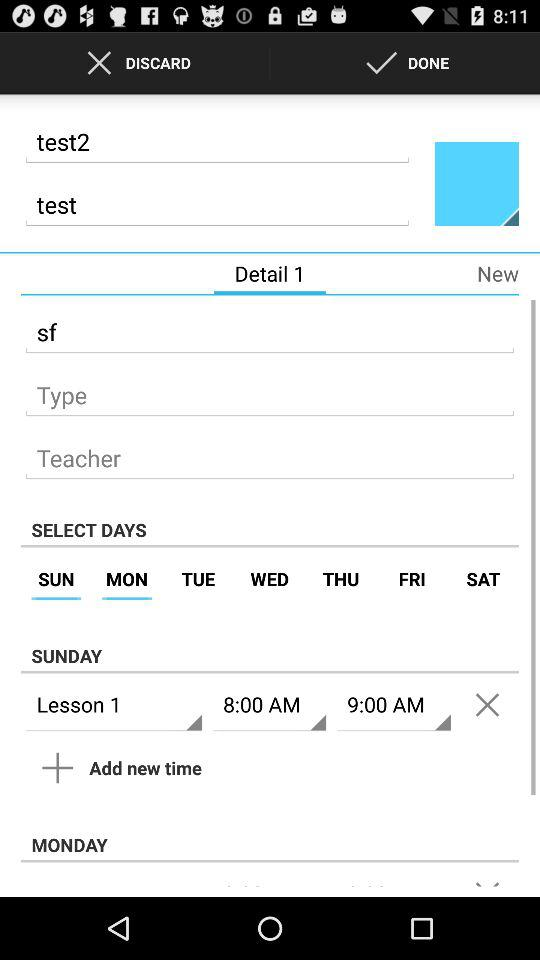On which day is the test going to be held? The test is going to be held on Sunday and Monday. 